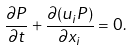Convert formula to latex. <formula><loc_0><loc_0><loc_500><loc_500>\frac { \partial P } { \partial t } + \frac { \partial ( u _ { i } P ) } { \partial x _ { i } } = 0 .</formula> 